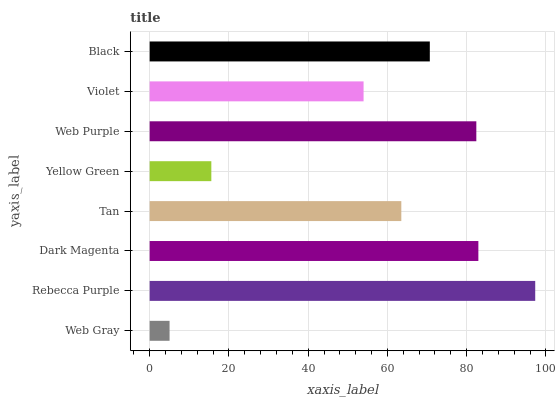Is Web Gray the minimum?
Answer yes or no. Yes. Is Rebecca Purple the maximum?
Answer yes or no. Yes. Is Dark Magenta the minimum?
Answer yes or no. No. Is Dark Magenta the maximum?
Answer yes or no. No. Is Rebecca Purple greater than Dark Magenta?
Answer yes or no. Yes. Is Dark Magenta less than Rebecca Purple?
Answer yes or no. Yes. Is Dark Magenta greater than Rebecca Purple?
Answer yes or no. No. Is Rebecca Purple less than Dark Magenta?
Answer yes or no. No. Is Black the high median?
Answer yes or no. Yes. Is Tan the low median?
Answer yes or no. Yes. Is Dark Magenta the high median?
Answer yes or no. No. Is Web Gray the low median?
Answer yes or no. No. 